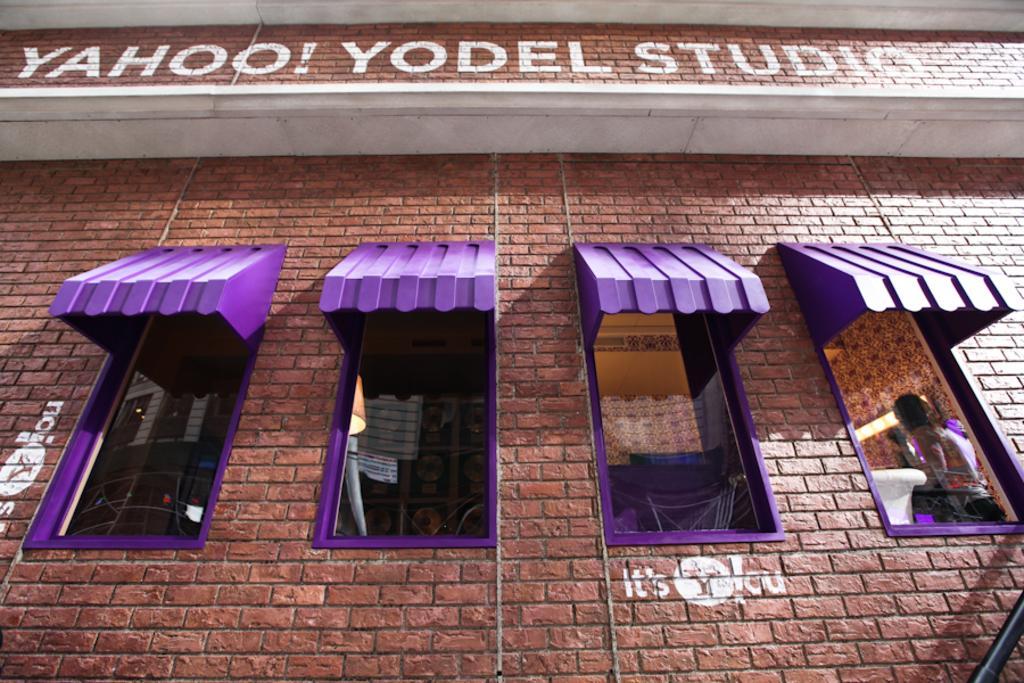Describe this image in one or two sentences. In this image we can see the brick wall, glass windows, window roofs which are in purple color, a person here and some text on the wall. 